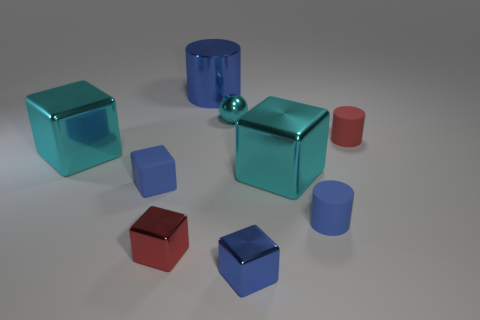Does the scene contain more cubes or cylinders? Upon examining the image, it is evident that there are more cylinders than cubes. Counting reveals there are four cylinders and three cubes in total.  What can you tell about the smallest object in the picture? The smallest object in the image is the tiny red rubber cylinder. It stands out not only because of its size but also due to its vivid color, which contrasts with the other objects in the scene. 